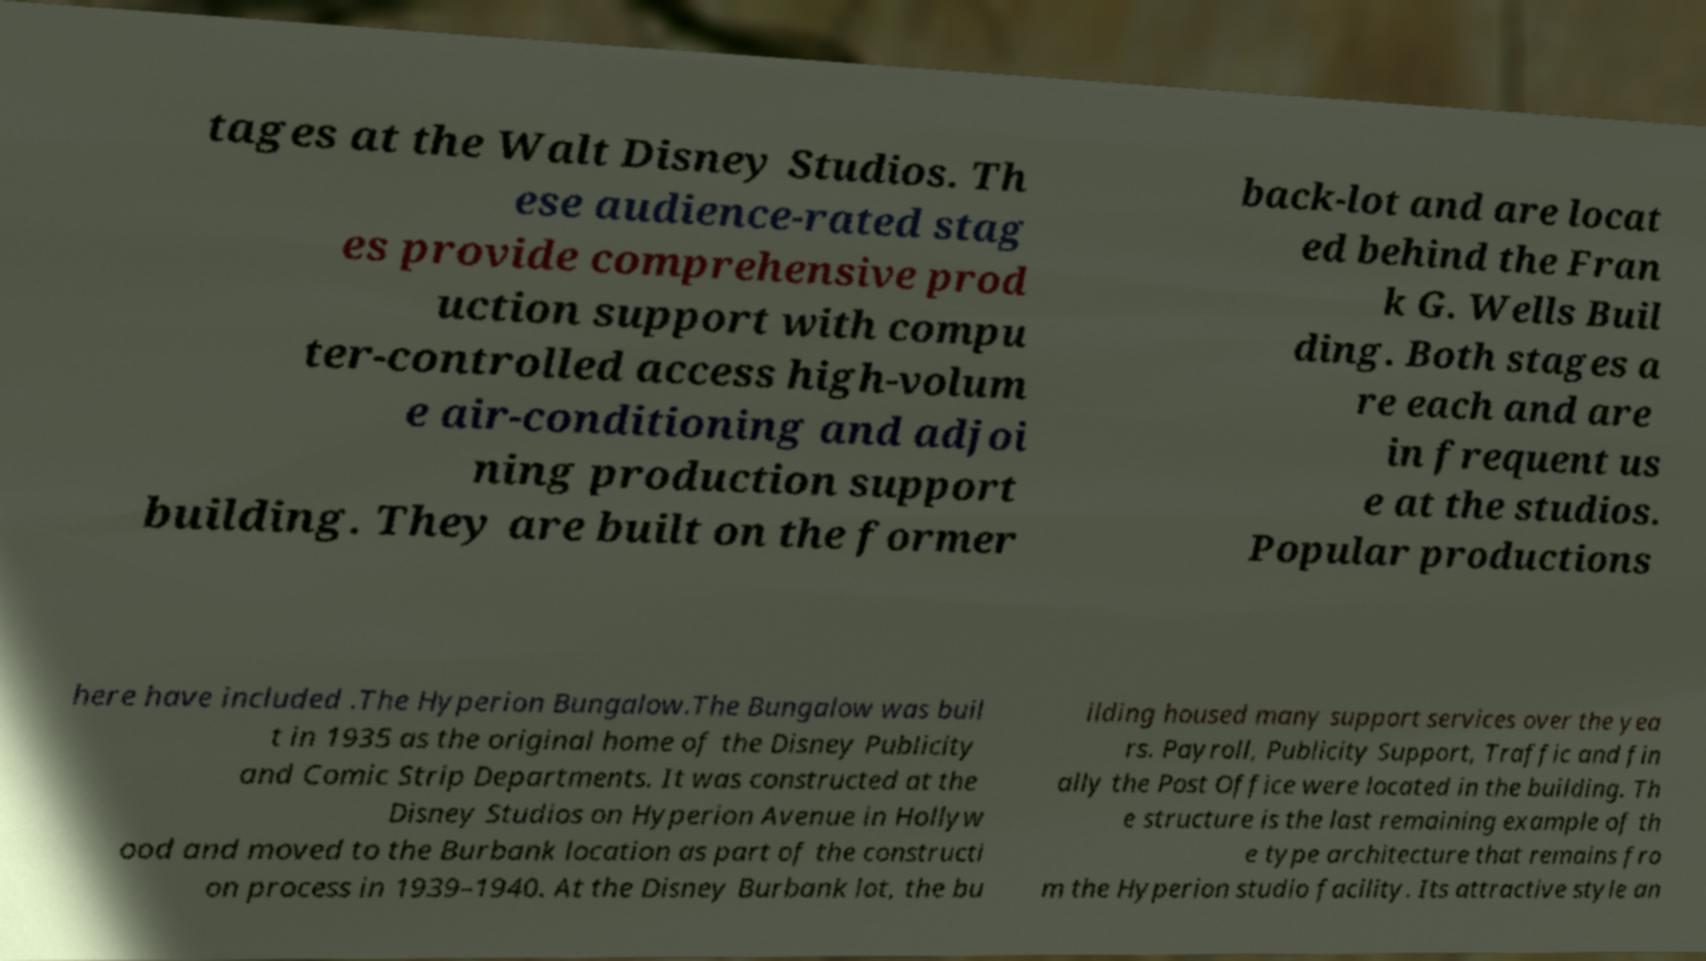For documentation purposes, I need the text within this image transcribed. Could you provide that? tages at the Walt Disney Studios. Th ese audience-rated stag es provide comprehensive prod uction support with compu ter-controlled access high-volum e air-conditioning and adjoi ning production support building. They are built on the former back-lot and are locat ed behind the Fran k G. Wells Buil ding. Both stages a re each and are in frequent us e at the studios. Popular productions here have included .The Hyperion Bungalow.The Bungalow was buil t in 1935 as the original home of the Disney Publicity and Comic Strip Departments. It was constructed at the Disney Studios on Hyperion Avenue in Hollyw ood and moved to the Burbank location as part of the constructi on process in 1939–1940. At the Disney Burbank lot, the bu ilding housed many support services over the yea rs. Payroll, Publicity Support, Traffic and fin ally the Post Office were located in the building. Th e structure is the last remaining example of th e type architecture that remains fro m the Hyperion studio facility. Its attractive style an 